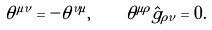<formula> <loc_0><loc_0><loc_500><loc_500>\theta ^ { \mu \nu } = - \theta ^ { \nu \mu } , \, \quad \theta ^ { \mu \rho } \hat { g } _ { \rho \nu } = 0 .</formula> 